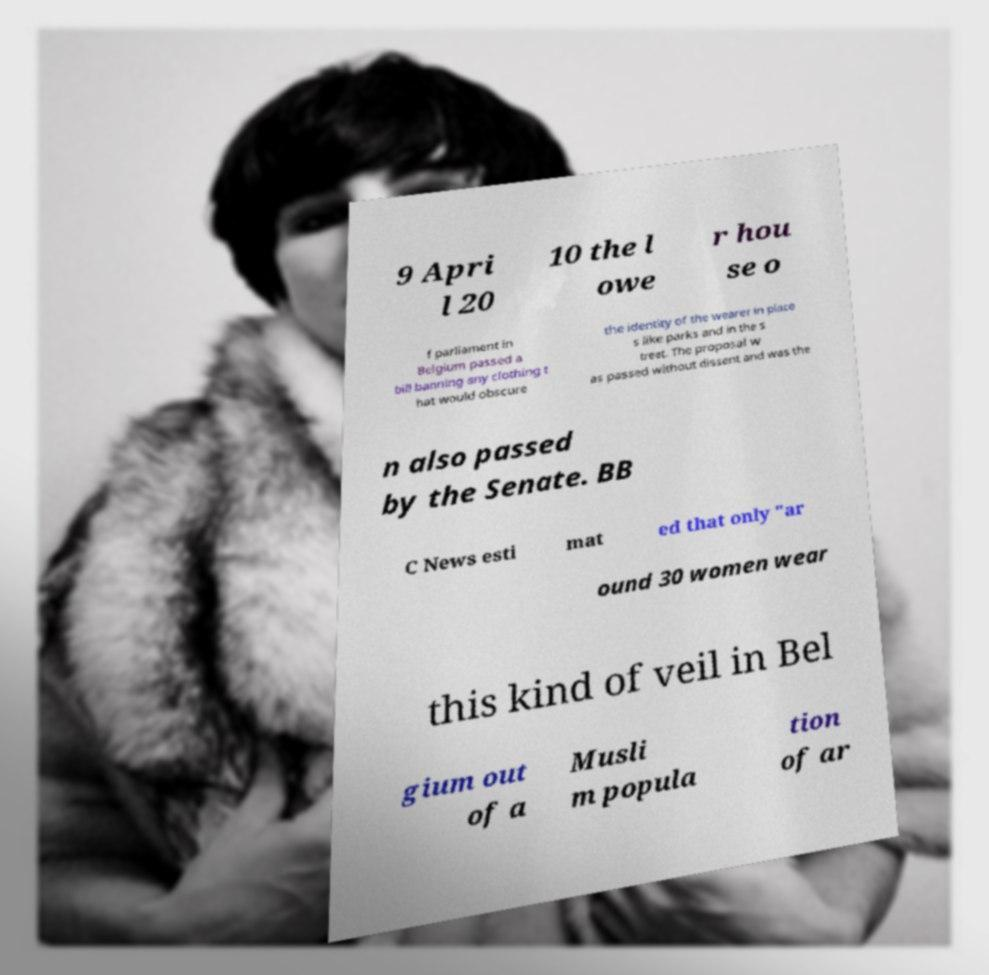For documentation purposes, I need the text within this image transcribed. Could you provide that? 9 Apri l 20 10 the l owe r hou se o f parliament in Belgium passed a bill banning any clothing t hat would obscure the identity of the wearer in place s like parks and in the s treet. The proposal w as passed without dissent and was the n also passed by the Senate. BB C News esti mat ed that only "ar ound 30 women wear this kind of veil in Bel gium out of a Musli m popula tion of ar 